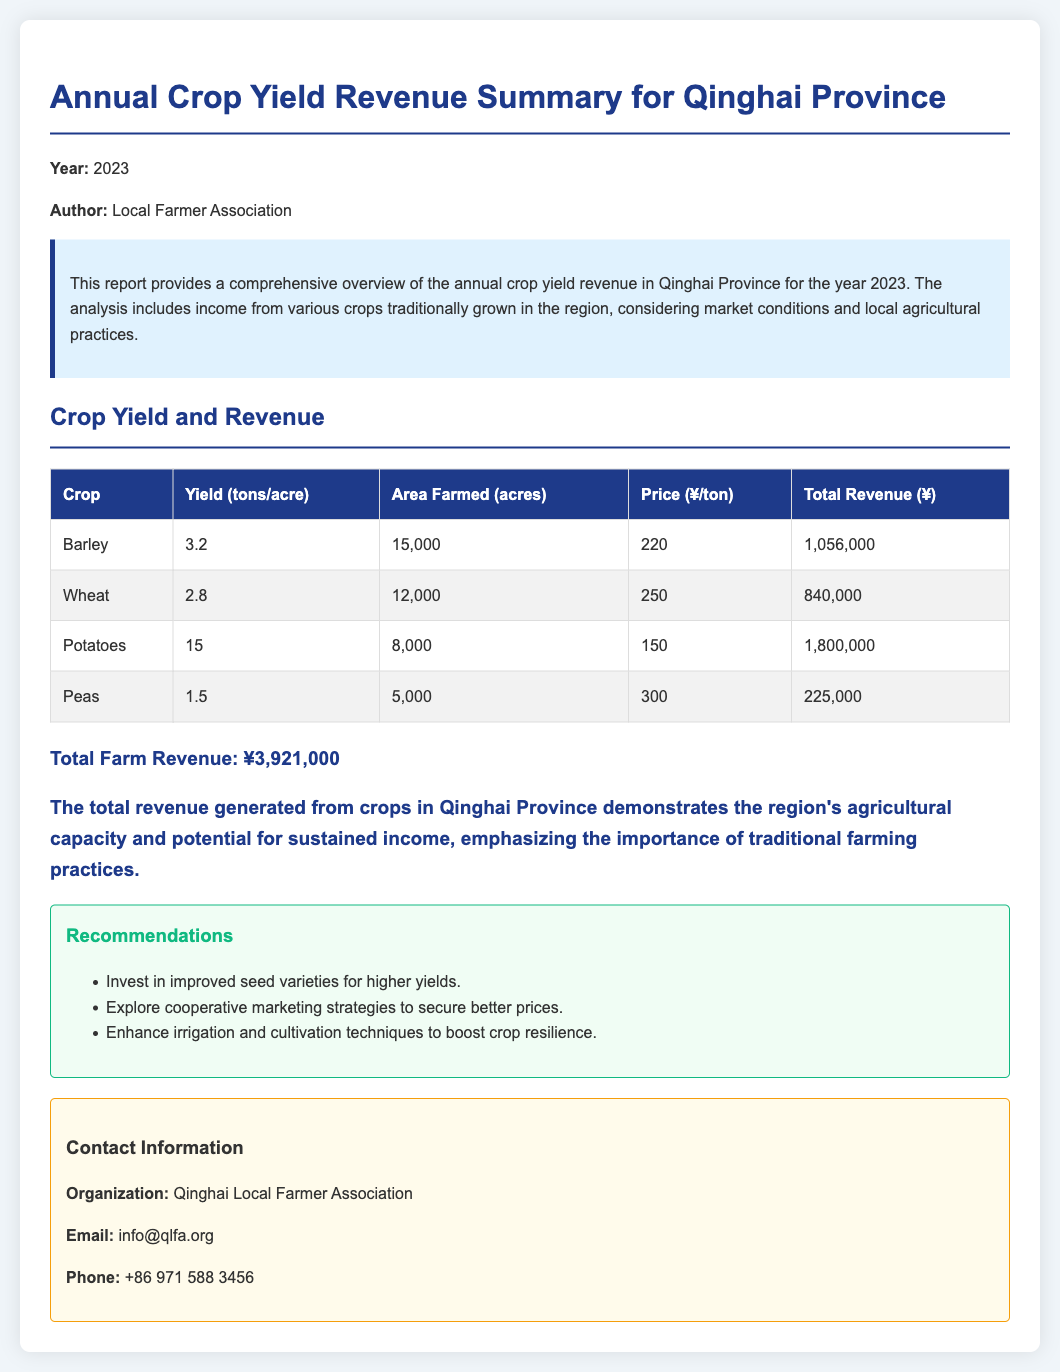what is the year of the report? The report provides the year within its content, which is specified at the top as the year being reported.
Answer: 2023 who authored the report? The author of the report is mentioned in the document's introduction, highlighting the organization responsible for compiling the information.
Answer: Local Farmer Association what is the total farm revenue? The total revenue is explicitly stated in the document, summarizing the income generated from various crops.
Answer: ¥3,921,000 which crop has the highest yield per acre? The yields for each crop are listed in the table, allowing for easy comparison to identify which one has the highest yield.
Answer: Potatoes how much revenue does barley generate? The revenue generated from barley is calculated based on its yield, area farmed, and price per ton, which is detailed in the crop revenue table.
Answer: ¥1,056,000 what recommendation is given regarding seed varieties? The recommendations section provides actionable insights for improving agricultural outcomes, specifically mentioning seed types.
Answer: Invest in improved seed varieties for higher yields how many acres are farmed for peas? The area farmed for each crop is provided in the revenue table, detailing the specific acreage dedicated to different crops.
Answer: 5,000 acres what price is set for wheat per ton? The document specifies the pricing for each crop, making it straightforward to find the price for wheat within the provided table.
Answer: ¥250 